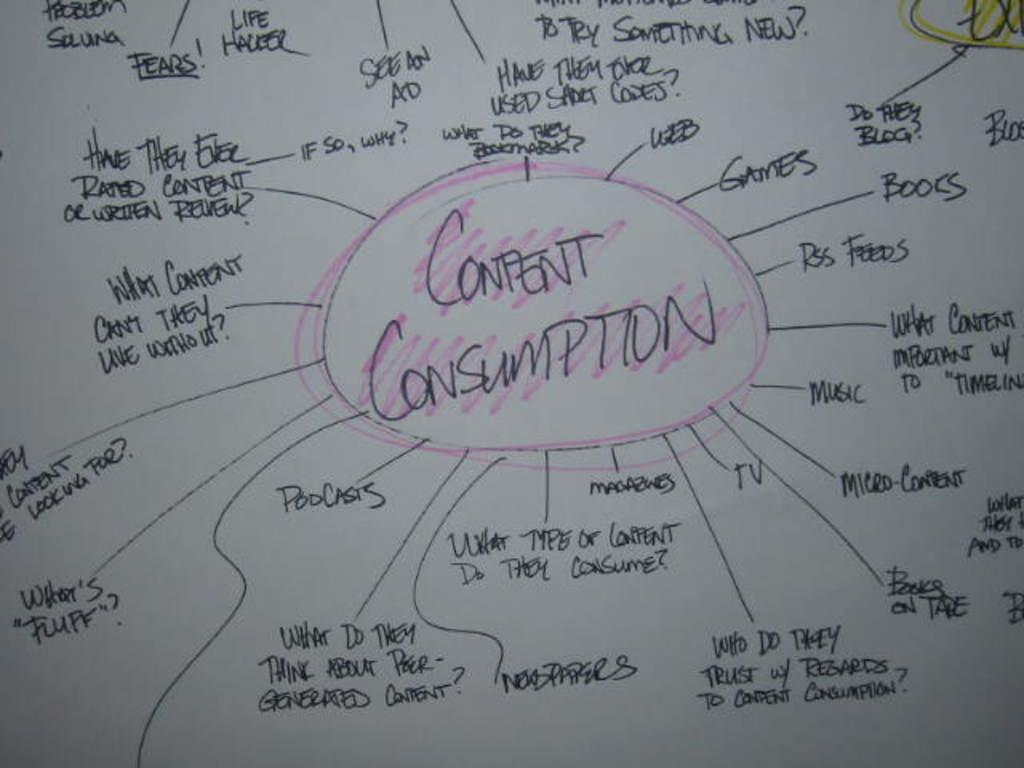<image>
Give a short and clear explanation of the subsequent image. A drawing is on a whiteboard with CONTENT CONSUMPTION in the middle and WEB, GAMES, MUSIC, TV are some other words around it. 